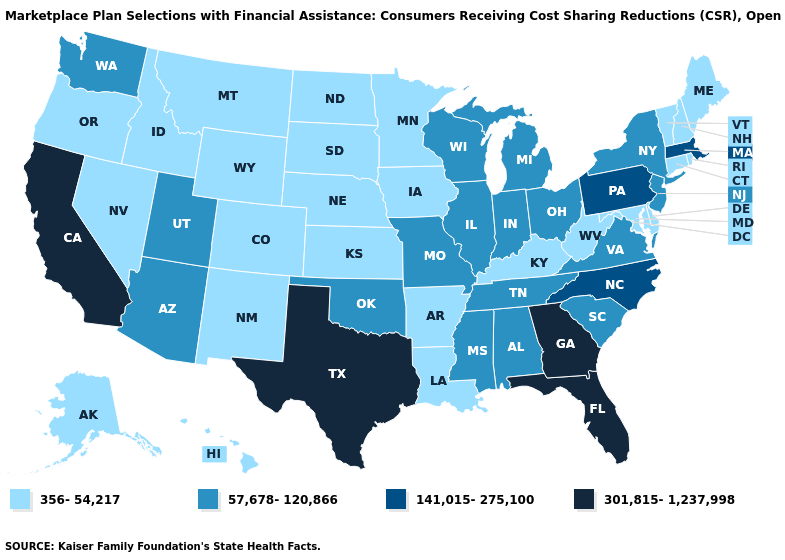What is the value of Iowa?
Concise answer only. 356-54,217. Name the states that have a value in the range 301,815-1,237,998?
Give a very brief answer. California, Florida, Georgia, Texas. Name the states that have a value in the range 356-54,217?
Be succinct. Alaska, Arkansas, Colorado, Connecticut, Delaware, Hawaii, Idaho, Iowa, Kansas, Kentucky, Louisiana, Maine, Maryland, Minnesota, Montana, Nebraska, Nevada, New Hampshire, New Mexico, North Dakota, Oregon, Rhode Island, South Dakota, Vermont, West Virginia, Wyoming. What is the lowest value in states that border Tennessee?
Keep it brief. 356-54,217. Among the states that border New Mexico , does Colorado have the lowest value?
Be succinct. Yes. Does the first symbol in the legend represent the smallest category?
Quick response, please. Yes. Name the states that have a value in the range 57,678-120,866?
Answer briefly. Alabama, Arizona, Illinois, Indiana, Michigan, Mississippi, Missouri, New Jersey, New York, Ohio, Oklahoma, South Carolina, Tennessee, Utah, Virginia, Washington, Wisconsin. What is the highest value in the USA?
Keep it brief. 301,815-1,237,998. What is the value of New Jersey?
Write a very short answer. 57,678-120,866. Name the states that have a value in the range 301,815-1,237,998?
Short answer required. California, Florida, Georgia, Texas. Does the map have missing data?
Keep it brief. No. What is the value of West Virginia?
Keep it brief. 356-54,217. What is the value of Tennessee?
Keep it brief. 57,678-120,866. Does the map have missing data?
Keep it brief. No. 